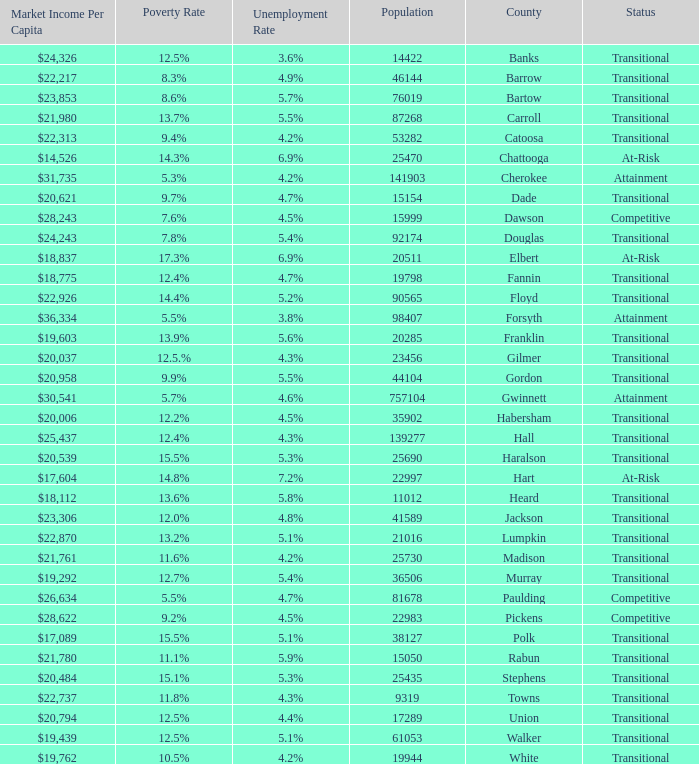What is the status of the county that has a 17.3% poverty rate? At-Risk. 